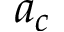<formula> <loc_0><loc_0><loc_500><loc_500>a _ { c }</formula> 